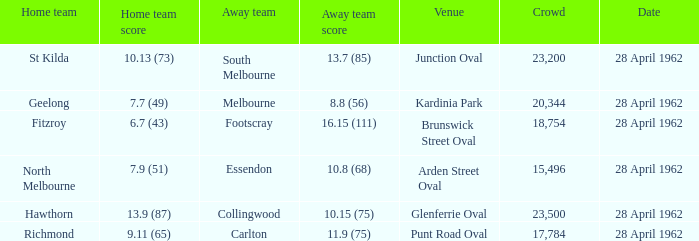What was the crowd size when there was a home team score of 10.13 (73)? 23200.0. 